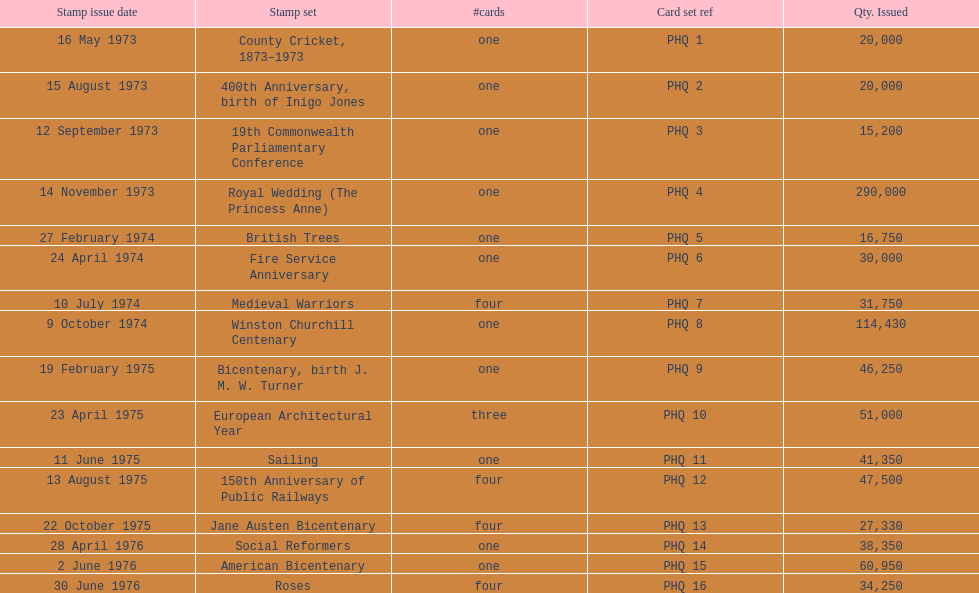Which card was given out most? Royal Wedding (The Princess Anne). 